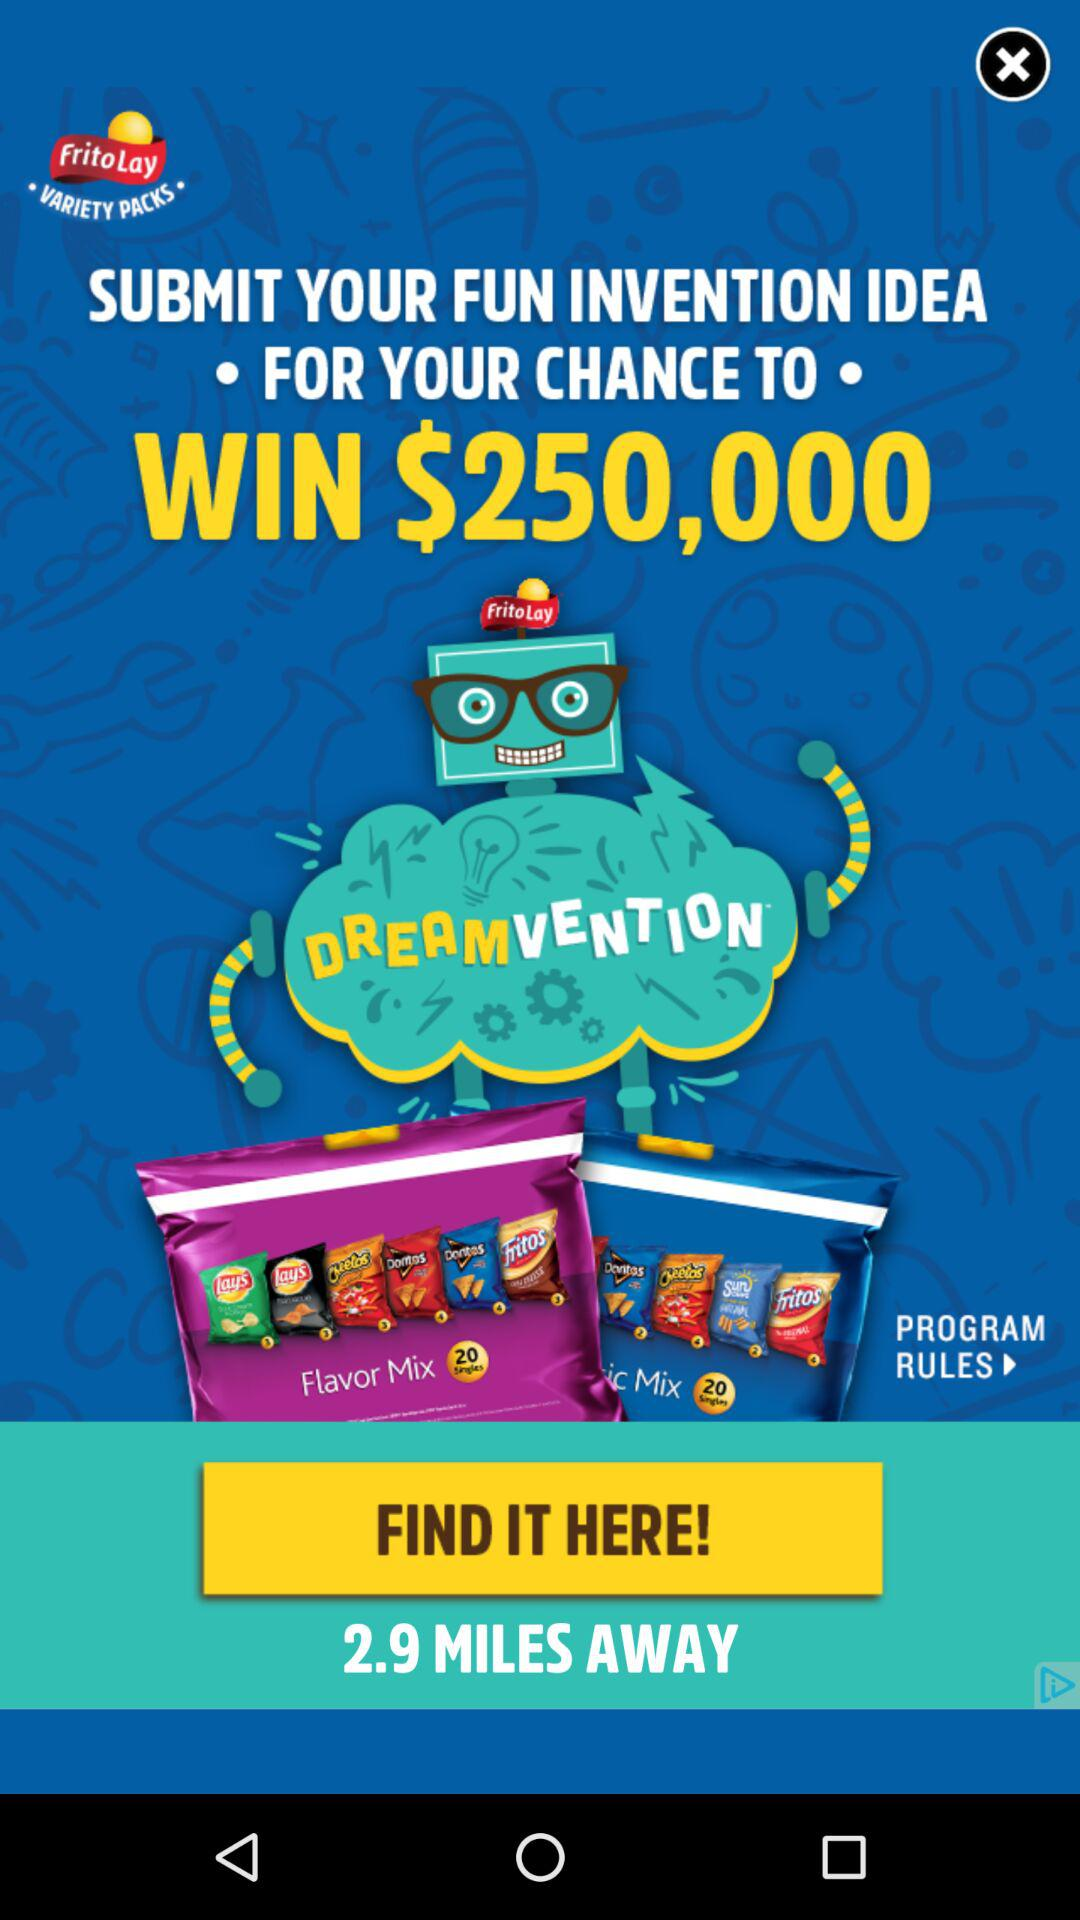How many miles away is the store?
Answer the question using a single word or phrase. 2.9 